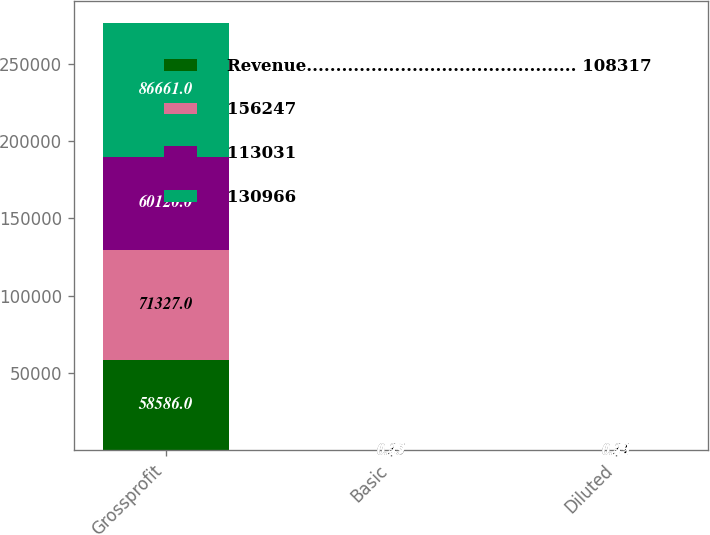<chart> <loc_0><loc_0><loc_500><loc_500><stacked_bar_chart><ecel><fcel>Grossprofit<fcel>Basic<fcel>Diluted<nl><fcel>Revenue.............................................. 108317<fcel>58586<fcel>0.21<fcel>0.19<nl><fcel>156247<fcel>71327<fcel>0.35<fcel>0.31<nl><fcel>113031<fcel>60120<fcel>0.25<fcel>0.22<nl><fcel>130966<fcel>86661<fcel>0.49<fcel>0.43<nl></chart> 